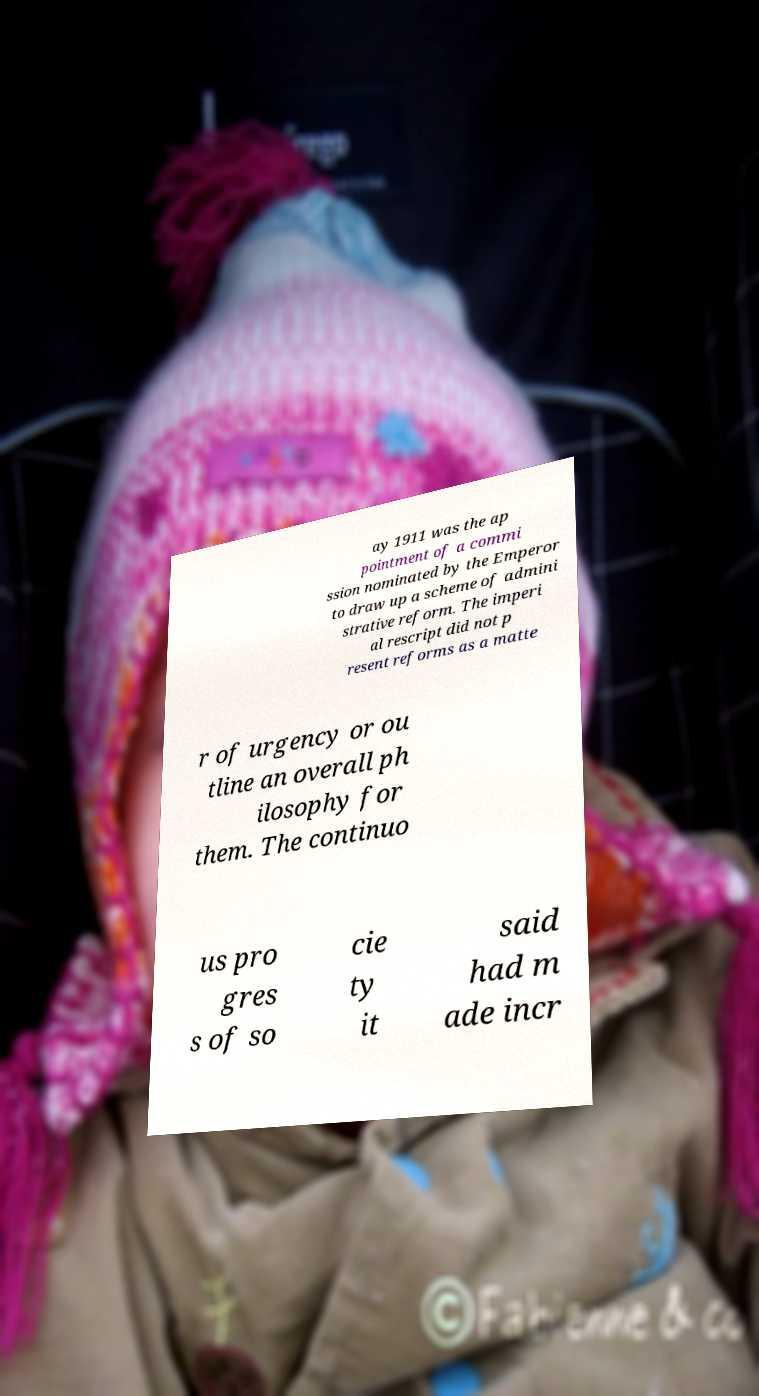Can you accurately transcribe the text from the provided image for me? ay 1911 was the ap pointment of a commi ssion nominated by the Emperor to draw up a scheme of admini strative reform. The imperi al rescript did not p resent reforms as a matte r of urgency or ou tline an overall ph ilosophy for them. The continuo us pro gres s of so cie ty it said had m ade incr 